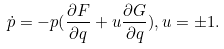Convert formula to latex. <formula><loc_0><loc_0><loc_500><loc_500>\dot { p } = - p ( \frac { \partial F } { \partial q } + u \frac { \partial G } { \partial q } ) , u = \pm 1 .</formula> 